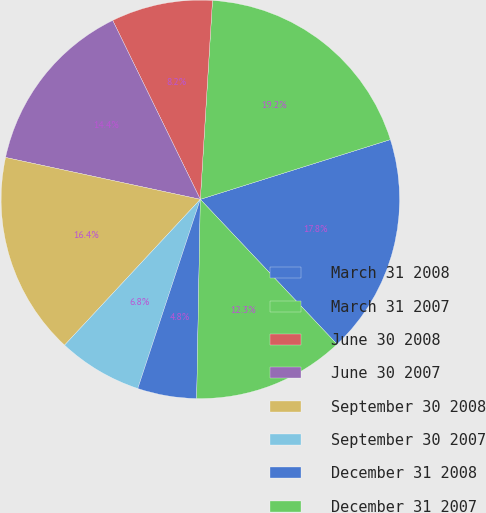<chart> <loc_0><loc_0><loc_500><loc_500><pie_chart><fcel>March 31 2008<fcel>March 31 2007<fcel>June 30 2008<fcel>June 30 2007<fcel>September 30 2008<fcel>September 30 2007<fcel>December 31 2008<fcel>December 31 2007<nl><fcel>17.81%<fcel>19.18%<fcel>8.22%<fcel>14.38%<fcel>16.44%<fcel>6.85%<fcel>4.79%<fcel>12.33%<nl></chart> 